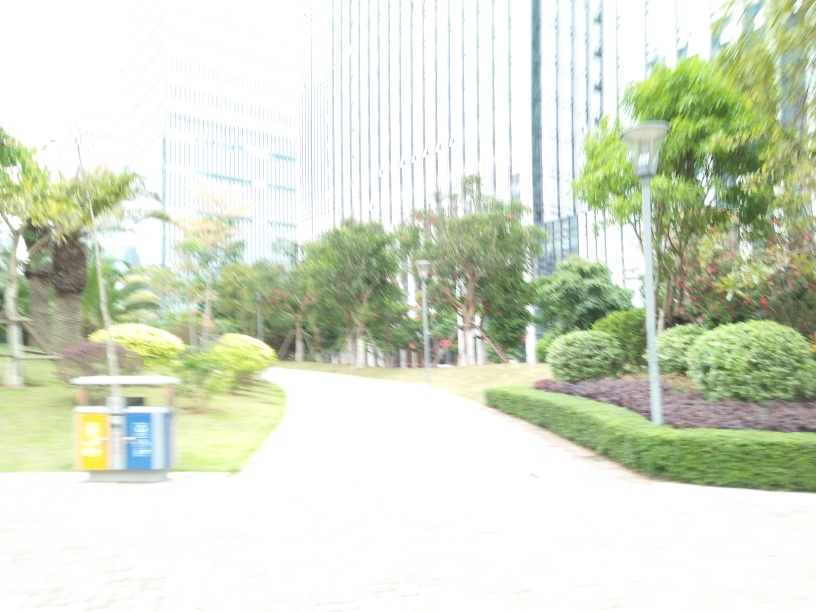Could the quality of the photo be an artistic choice? It's possible that the overexposure is an intentional artistic expression, aiming to convey a dreamlike or ethereal quality to the scene, though it typically signifies a technical mishap in photography. 